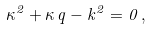<formula> <loc_0><loc_0><loc_500><loc_500>\kappa ^ { 2 } + \kappa \, q - k ^ { 2 } = 0 \, { , }</formula> 